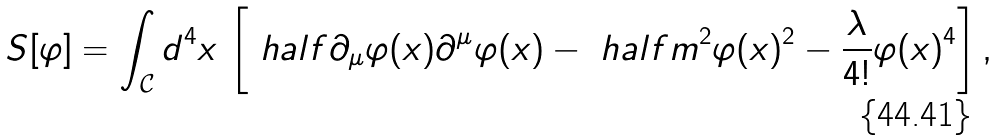Convert formula to latex. <formula><loc_0><loc_0><loc_500><loc_500>S [ \varphi ] = \int _ { \mathcal { C } } d ^ { 4 } x \, \left [ \ h a l f \partial _ { \mu } \varphi ( x ) \partial ^ { \mu } \varphi ( x ) - \ h a l f m ^ { 2 } \varphi ( x ) ^ { 2 } - \frac { \lambda } { 4 ! } \varphi ( x ) ^ { 4 } \right ] ,</formula> 